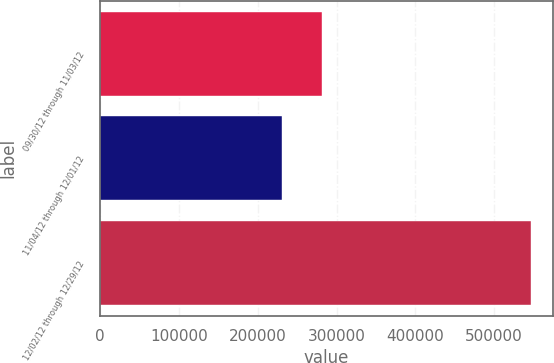<chart> <loc_0><loc_0><loc_500><loc_500><bar_chart><fcel>09/30/12 through 11/03/12<fcel>11/04/12 through 12/01/12<fcel>12/02/12 through 12/29/12<nl><fcel>281428<fcel>230700<fcel>546899<nl></chart> 